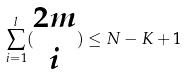<formula> <loc_0><loc_0><loc_500><loc_500>\sum _ { i = 1 } ^ { l } ( \begin{matrix} 2 m \\ i \end{matrix} ) \leq N - K + 1</formula> 